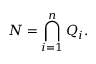Convert formula to latex. <formula><loc_0><loc_0><loc_500><loc_500>N = \bigcap _ { i = 1 } ^ { n } Q _ { i } .</formula> 